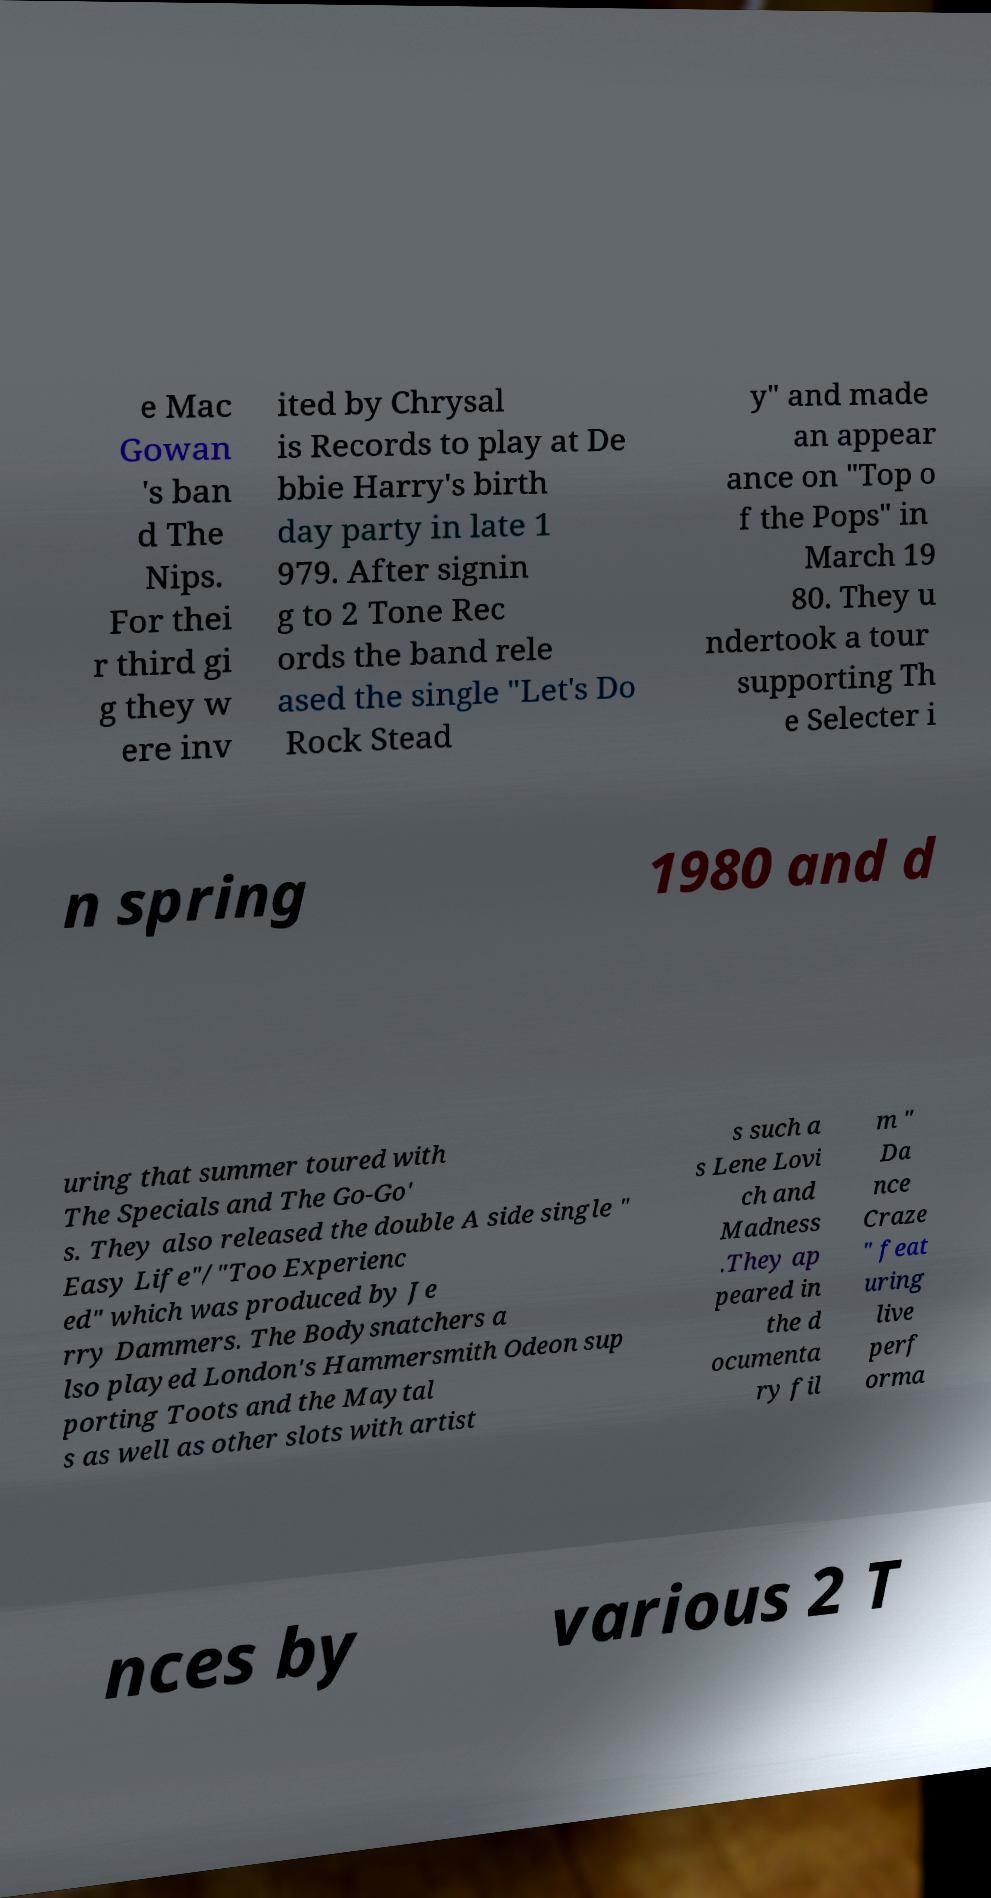Please read and relay the text visible in this image. What does it say? e Mac Gowan 's ban d The Nips. For thei r third gi g they w ere inv ited by Chrysal is Records to play at De bbie Harry's birth day party in late 1 979. After signin g to 2 Tone Rec ords the band rele ased the single "Let's Do Rock Stead y" and made an appear ance on "Top o f the Pops" in March 19 80. They u ndertook a tour supporting Th e Selecter i n spring 1980 and d uring that summer toured with The Specials and The Go-Go' s. They also released the double A side single " Easy Life"/"Too Experienc ed" which was produced by Je rry Dammers. The Bodysnatchers a lso played London's Hammersmith Odeon sup porting Toots and the Maytal s as well as other slots with artist s such a s Lene Lovi ch and Madness .They ap peared in the d ocumenta ry fil m " Da nce Craze " feat uring live perf orma nces by various 2 T 